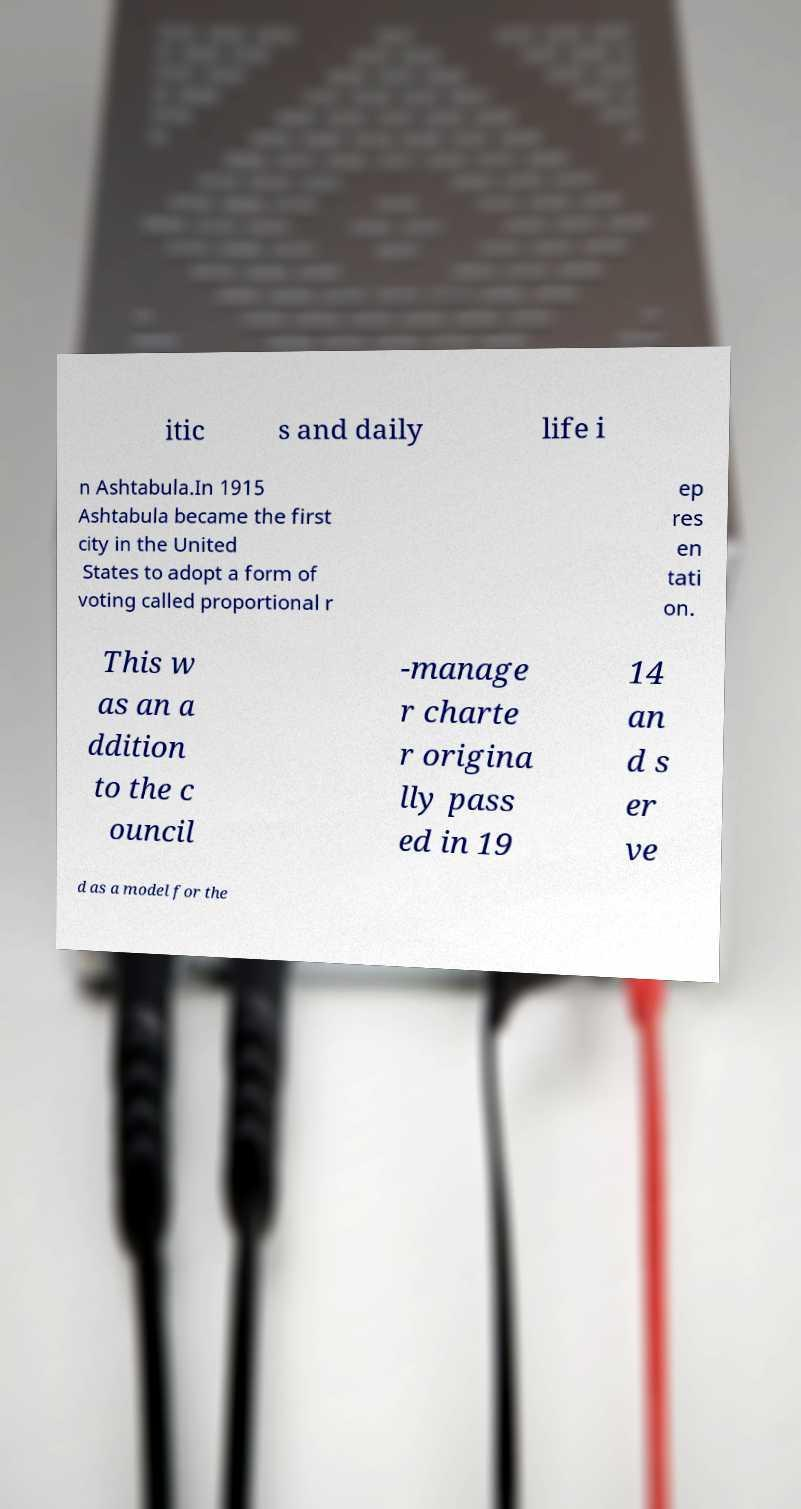Could you extract and type out the text from this image? itic s and daily life i n Ashtabula.In 1915 Ashtabula became the first city in the United States to adopt a form of voting called proportional r ep res en tati on. This w as an a ddition to the c ouncil -manage r charte r origina lly pass ed in 19 14 an d s er ve d as a model for the 